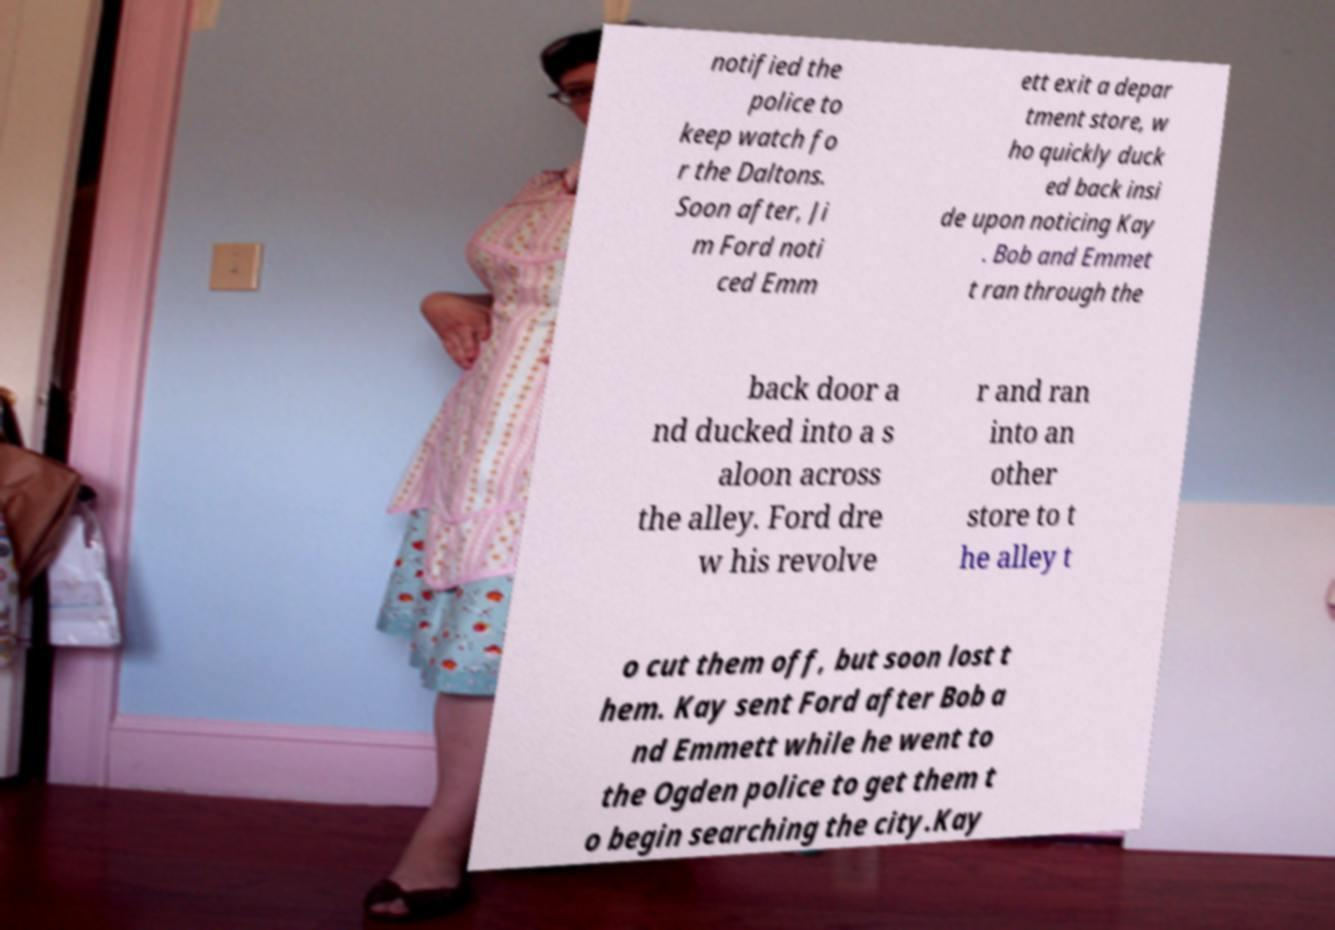There's text embedded in this image that I need extracted. Can you transcribe it verbatim? notified the police to keep watch fo r the Daltons. Soon after, Ji m Ford noti ced Emm ett exit a depar tment store, w ho quickly duck ed back insi de upon noticing Kay . Bob and Emmet t ran through the back door a nd ducked into a s aloon across the alley. Ford dre w his revolve r and ran into an other store to t he alley t o cut them off, but soon lost t hem. Kay sent Ford after Bob a nd Emmett while he went to the Ogden police to get them t o begin searching the city.Kay 